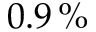<formula> <loc_0><loc_0><loc_500><loc_500>0 . 9 \, \%</formula> 